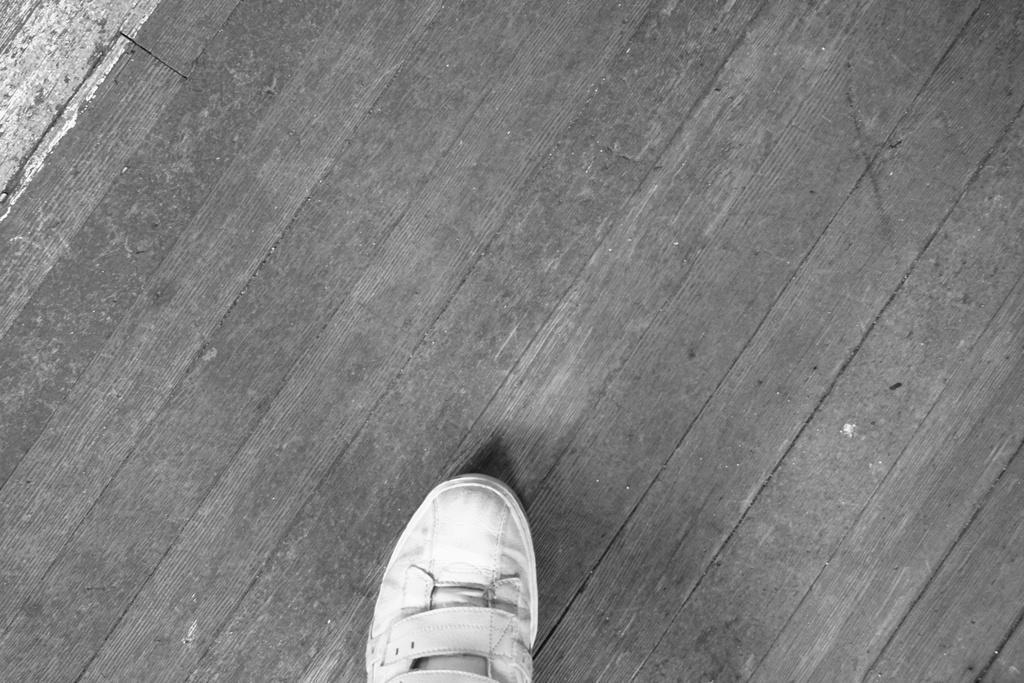Can you describe this image briefly? This is a black and white image, on the bottom, there is a shoe on a wooden surface. 